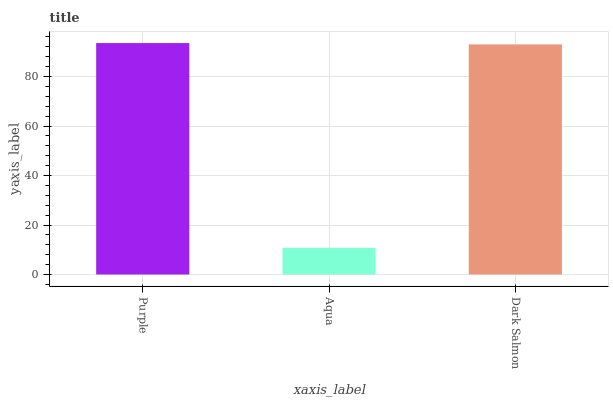Is Aqua the minimum?
Answer yes or no. Yes. Is Purple the maximum?
Answer yes or no. Yes. Is Dark Salmon the minimum?
Answer yes or no. No. Is Dark Salmon the maximum?
Answer yes or no. No. Is Dark Salmon greater than Aqua?
Answer yes or no. Yes. Is Aqua less than Dark Salmon?
Answer yes or no. Yes. Is Aqua greater than Dark Salmon?
Answer yes or no. No. Is Dark Salmon less than Aqua?
Answer yes or no. No. Is Dark Salmon the high median?
Answer yes or no. Yes. Is Dark Salmon the low median?
Answer yes or no. Yes. Is Purple the high median?
Answer yes or no. No. Is Purple the low median?
Answer yes or no. No. 